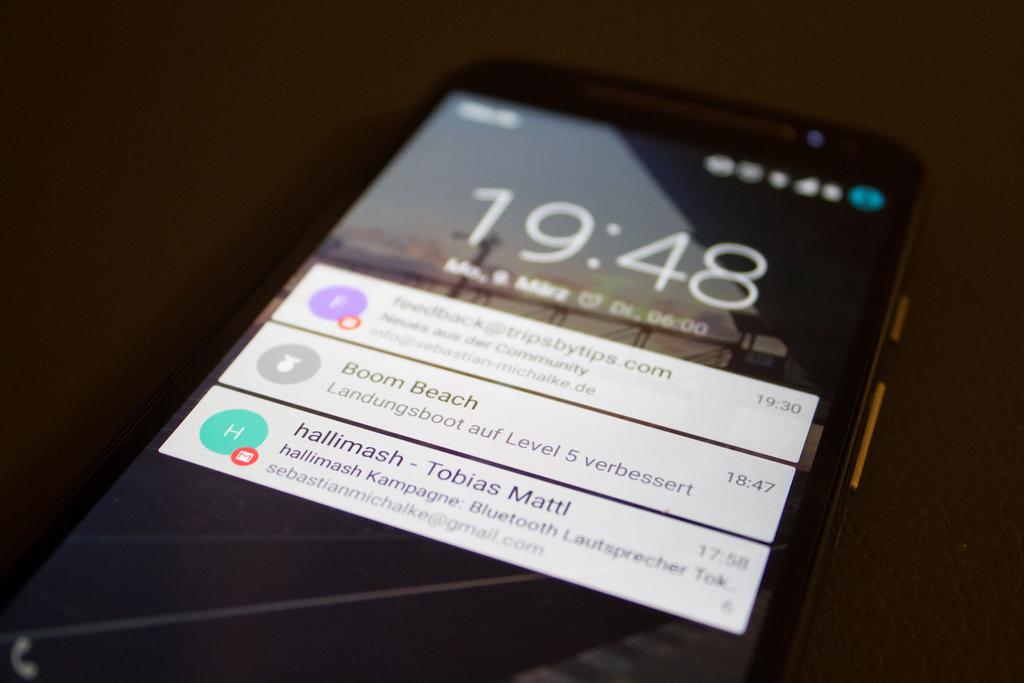What is the time shown on the phone?
Provide a succinct answer. 19:48. Who sent the email?
Provide a succinct answer. Tobias mattl. 